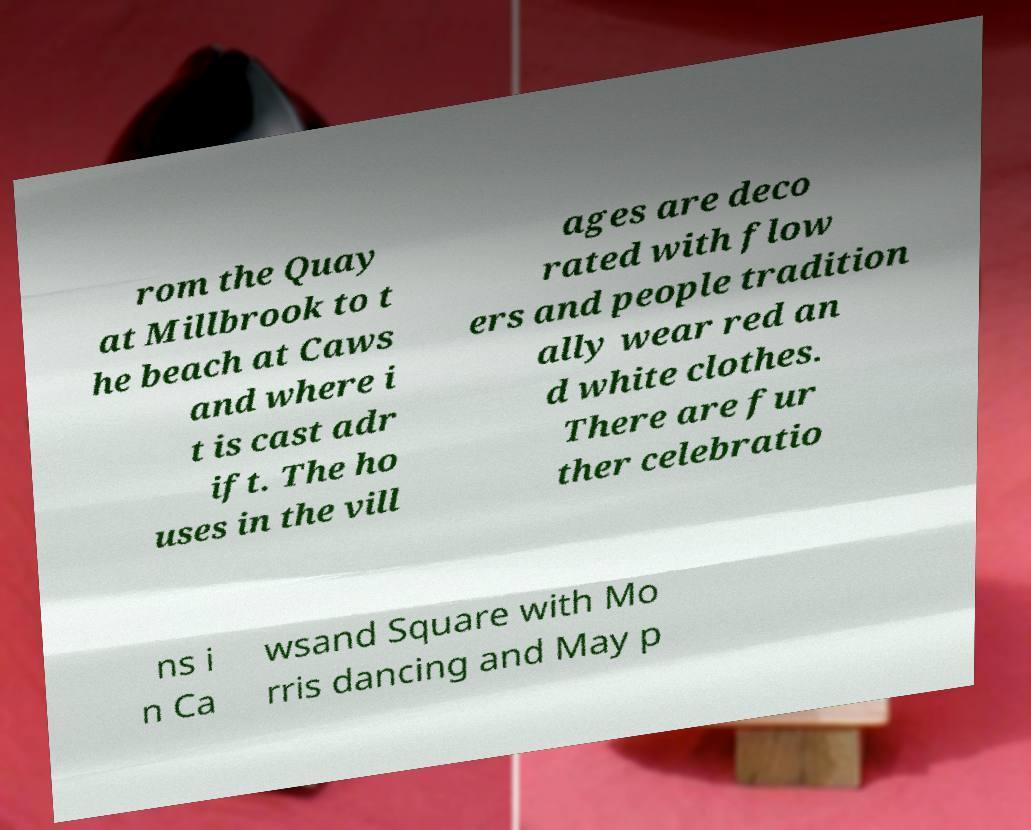I need the written content from this picture converted into text. Can you do that? rom the Quay at Millbrook to t he beach at Caws and where i t is cast adr ift. The ho uses in the vill ages are deco rated with flow ers and people tradition ally wear red an d white clothes. There are fur ther celebratio ns i n Ca wsand Square with Mo rris dancing and May p 